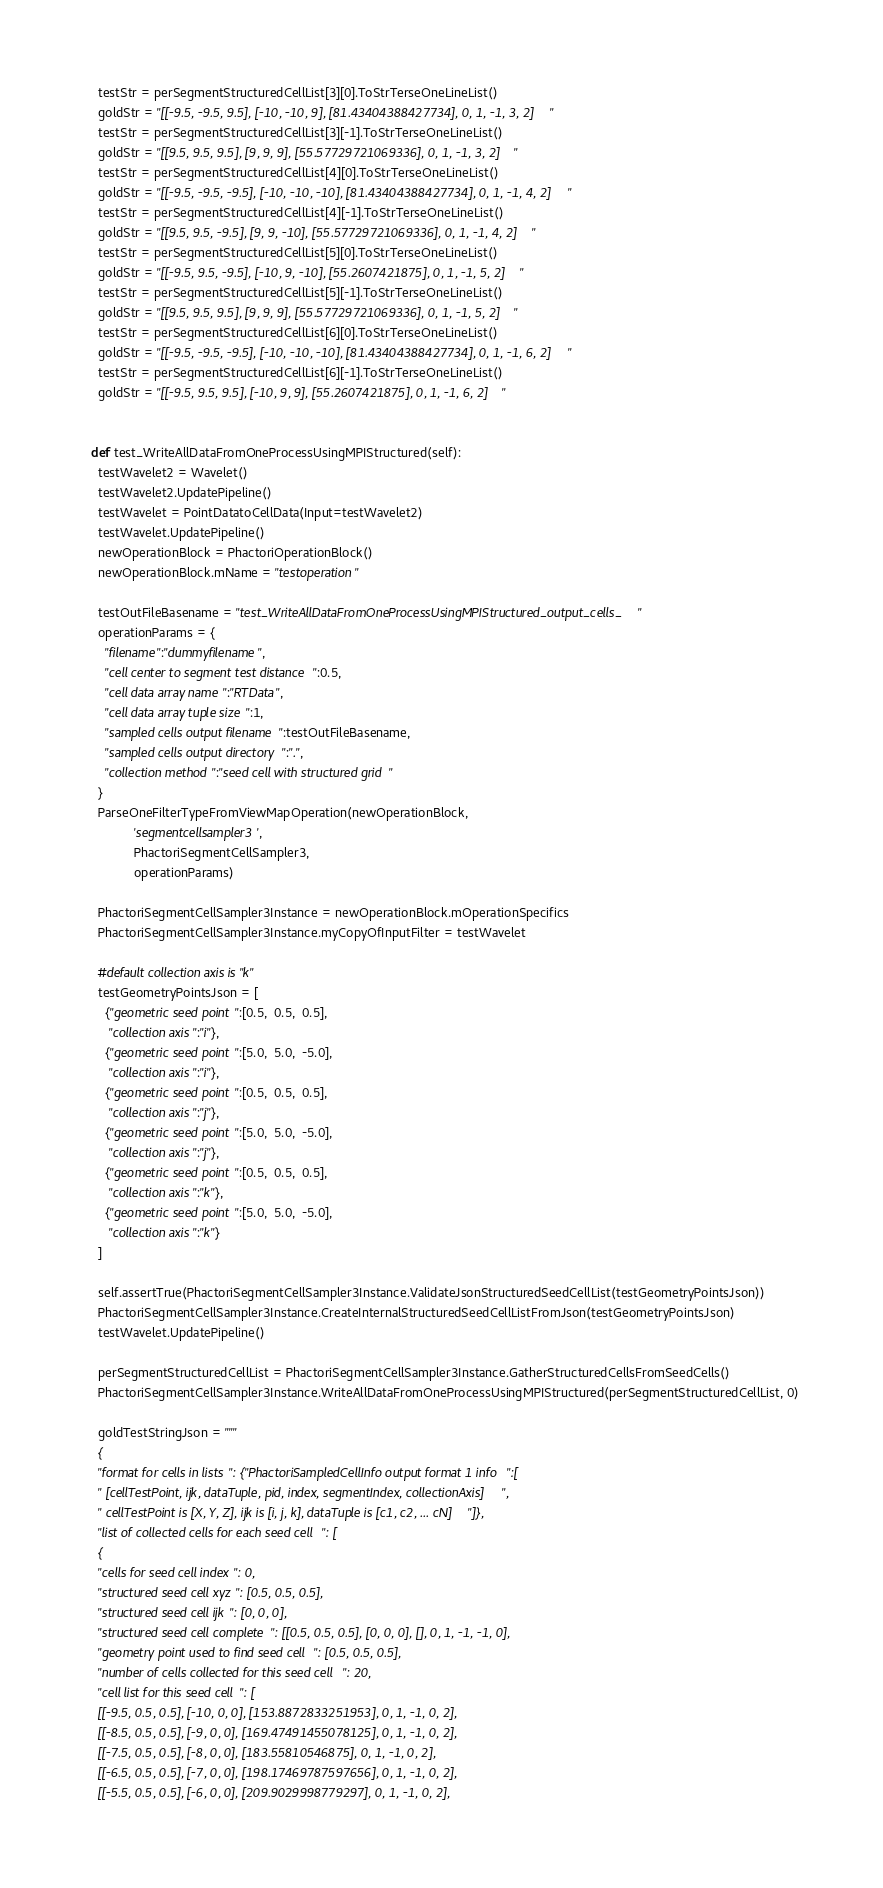<code> <loc_0><loc_0><loc_500><loc_500><_Python_>    testStr = perSegmentStructuredCellList[3][0].ToStrTerseOneLineList()
    goldStr = "[[-9.5, -9.5, 9.5], [-10, -10, 9], [81.43404388427734], 0, 1, -1, 3, 2]"
    testStr = perSegmentStructuredCellList[3][-1].ToStrTerseOneLineList()
    goldStr = "[[9.5, 9.5, 9.5], [9, 9, 9], [55.57729721069336], 0, 1, -1, 3, 2]"
    testStr = perSegmentStructuredCellList[4][0].ToStrTerseOneLineList()
    goldStr = "[[-9.5, -9.5, -9.5], [-10, -10, -10], [81.43404388427734], 0, 1, -1, 4, 2]"
    testStr = perSegmentStructuredCellList[4][-1].ToStrTerseOneLineList()
    goldStr = "[[9.5, 9.5, -9.5], [9, 9, -10], [55.57729721069336], 0, 1, -1, 4, 2]"
    testStr = perSegmentStructuredCellList[5][0].ToStrTerseOneLineList()
    goldStr = "[[-9.5, 9.5, -9.5], [-10, 9, -10], [55.2607421875], 0, 1, -1, 5, 2]"
    testStr = perSegmentStructuredCellList[5][-1].ToStrTerseOneLineList()
    goldStr = "[[9.5, 9.5, 9.5], [9, 9, 9], [55.57729721069336], 0, 1, -1, 5, 2]"
    testStr = perSegmentStructuredCellList[6][0].ToStrTerseOneLineList()
    goldStr = "[[-9.5, -9.5, -9.5], [-10, -10, -10], [81.43404388427734], 0, 1, -1, 6, 2]"
    testStr = perSegmentStructuredCellList[6][-1].ToStrTerseOneLineList()
    goldStr = "[[-9.5, 9.5, 9.5], [-10, 9, 9], [55.2607421875], 0, 1, -1, 6, 2]"


  def test_WriteAllDataFromOneProcessUsingMPIStructured(self):
    testWavelet2 = Wavelet()
    testWavelet2.UpdatePipeline()
    testWavelet = PointDatatoCellData(Input=testWavelet2)
    testWavelet.UpdatePipeline()
    newOperationBlock = PhactoriOperationBlock()
    newOperationBlock.mName = "testoperation"

    testOutFileBasename = "test_WriteAllDataFromOneProcessUsingMPIStructured_output_cells_"
    operationParams = {
      "filename":"dummyfilename",
      "cell center to segment test distance":0.5,
      "cell data array name":"RTData",
      "cell data array tuple size":1,
      "sampled cells output filename":testOutFileBasename,
      "sampled cells output directory":".",
      "collection method":"seed cell with structured grid"
    }
    ParseOneFilterTypeFromViewMapOperation(newOperationBlock,
              'segmentcellsampler3',
              PhactoriSegmentCellSampler3,
              operationParams)

    PhactoriSegmentCellSampler3Instance = newOperationBlock.mOperationSpecifics
    PhactoriSegmentCellSampler3Instance.myCopyOfInputFilter = testWavelet

    #default collection axis is "k"
    testGeometryPointsJson = [
      {"geometric seed point":[0.5,  0.5,  0.5],
       "collection axis":"i"},
      {"geometric seed point":[5.0,  5.0,  -5.0],
       "collection axis":"i"},
      {"geometric seed point":[0.5,  0.5,  0.5],
       "collection axis":"j"},
      {"geometric seed point":[5.0,  5.0,  -5.0],
       "collection axis":"j"},
      {"geometric seed point":[0.5,  0.5,  0.5],
       "collection axis":"k"},
      {"geometric seed point":[5.0,  5.0,  -5.0],
       "collection axis":"k"}
    ]

    self.assertTrue(PhactoriSegmentCellSampler3Instance.ValidateJsonStructuredSeedCellList(testGeometryPointsJson))
    PhactoriSegmentCellSampler3Instance.CreateInternalStructuredSeedCellListFromJson(testGeometryPointsJson)
    testWavelet.UpdatePipeline()

    perSegmentStructuredCellList = PhactoriSegmentCellSampler3Instance.GatherStructuredCellsFromSeedCells()
    PhactoriSegmentCellSampler3Instance.WriteAllDataFromOneProcessUsingMPIStructured(perSegmentStructuredCellList, 0)

    goldTestStringJson = """
    {
    "format for cells in lists": {"PhactoriSampledCellInfo output format 1 info":[
    " [cellTestPoint, ijk, dataTuple, pid, index, segmentIndex, collectionAxis]",
    " cellTestPoint is [X, Y, Z], ijk is [i, j, k], dataTuple is [c1, c2, ... cN]"]},
    "list of collected cells for each seed cell": [
    {
    "cells for seed cell index": 0,
    "structured seed cell xyz": [0.5, 0.5, 0.5],
    "structured seed cell ijk": [0, 0, 0],
    "structured seed cell complete": [[0.5, 0.5, 0.5], [0, 0, 0], [], 0, 1, -1, -1, 0],
    "geometry point used to find seed cell": [0.5, 0.5, 0.5],
    "number of cells collected for this seed cell": 20,
    "cell list for this seed cell": [
    [[-9.5, 0.5, 0.5], [-10, 0, 0], [153.8872833251953], 0, 1, -1, 0, 2],
    [[-8.5, 0.5, 0.5], [-9, 0, 0], [169.47491455078125], 0, 1, -1, 0, 2],
    [[-7.5, 0.5, 0.5], [-8, 0, 0], [183.55810546875], 0, 1, -1, 0, 2],
    [[-6.5, 0.5, 0.5], [-7, 0, 0], [198.17469787597656], 0, 1, -1, 0, 2],
    [[-5.5, 0.5, 0.5], [-6, 0, 0], [209.9029998779297], 0, 1, -1, 0, 2],</code> 